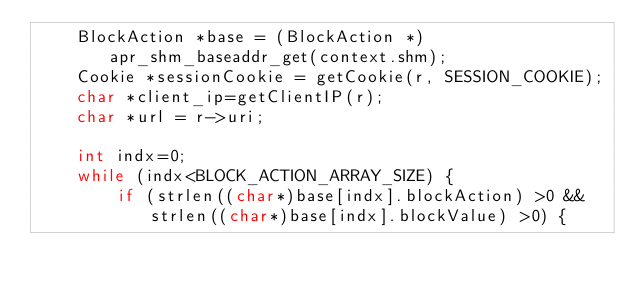<code> <loc_0><loc_0><loc_500><loc_500><_C_>    BlockAction *base = (BlockAction *)apr_shm_baseaddr_get(context.shm);
    Cookie *sessionCookie = getCookie(r, SESSION_COOKIE);
    char *client_ip=getClientIP(r);
    char *url = r->uri;

    int indx=0;
    while (indx<BLOCK_ACTION_ARRAY_SIZE) {
        if (strlen((char*)base[indx].blockAction) >0 && strlen((char*)base[indx].blockValue) >0) {</code> 